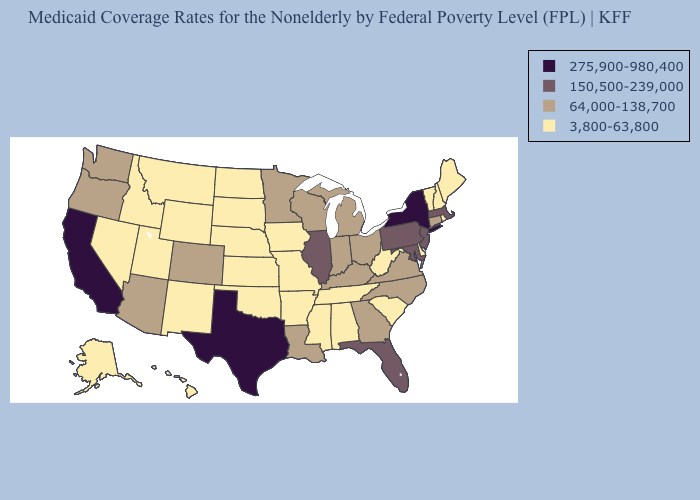Does Michigan have the same value as West Virginia?
Write a very short answer. No. Which states hav the highest value in the West?
Concise answer only. California. What is the highest value in the USA?
Write a very short answer. 275,900-980,400. What is the value of Arkansas?
Answer briefly. 3,800-63,800. Which states hav the highest value in the West?
Quick response, please. California. Which states have the lowest value in the Northeast?
Write a very short answer. Maine, New Hampshire, Rhode Island, Vermont. What is the lowest value in the USA?
Quick response, please. 3,800-63,800. Does Michigan have the same value as Louisiana?
Short answer required. Yes. Which states have the lowest value in the USA?
Concise answer only. Alabama, Alaska, Arkansas, Delaware, Hawaii, Idaho, Iowa, Kansas, Maine, Mississippi, Missouri, Montana, Nebraska, Nevada, New Hampshire, New Mexico, North Dakota, Oklahoma, Rhode Island, South Carolina, South Dakota, Tennessee, Utah, Vermont, West Virginia, Wyoming. What is the value of Alabama?
Write a very short answer. 3,800-63,800. Name the states that have a value in the range 150,500-239,000?
Concise answer only. Florida, Illinois, Maryland, Massachusetts, New Jersey, Pennsylvania. What is the value of New Mexico?
Quick response, please. 3,800-63,800. Does Illinois have a lower value than Texas?
Concise answer only. Yes. Does the first symbol in the legend represent the smallest category?
Quick response, please. No. Is the legend a continuous bar?
Concise answer only. No. 